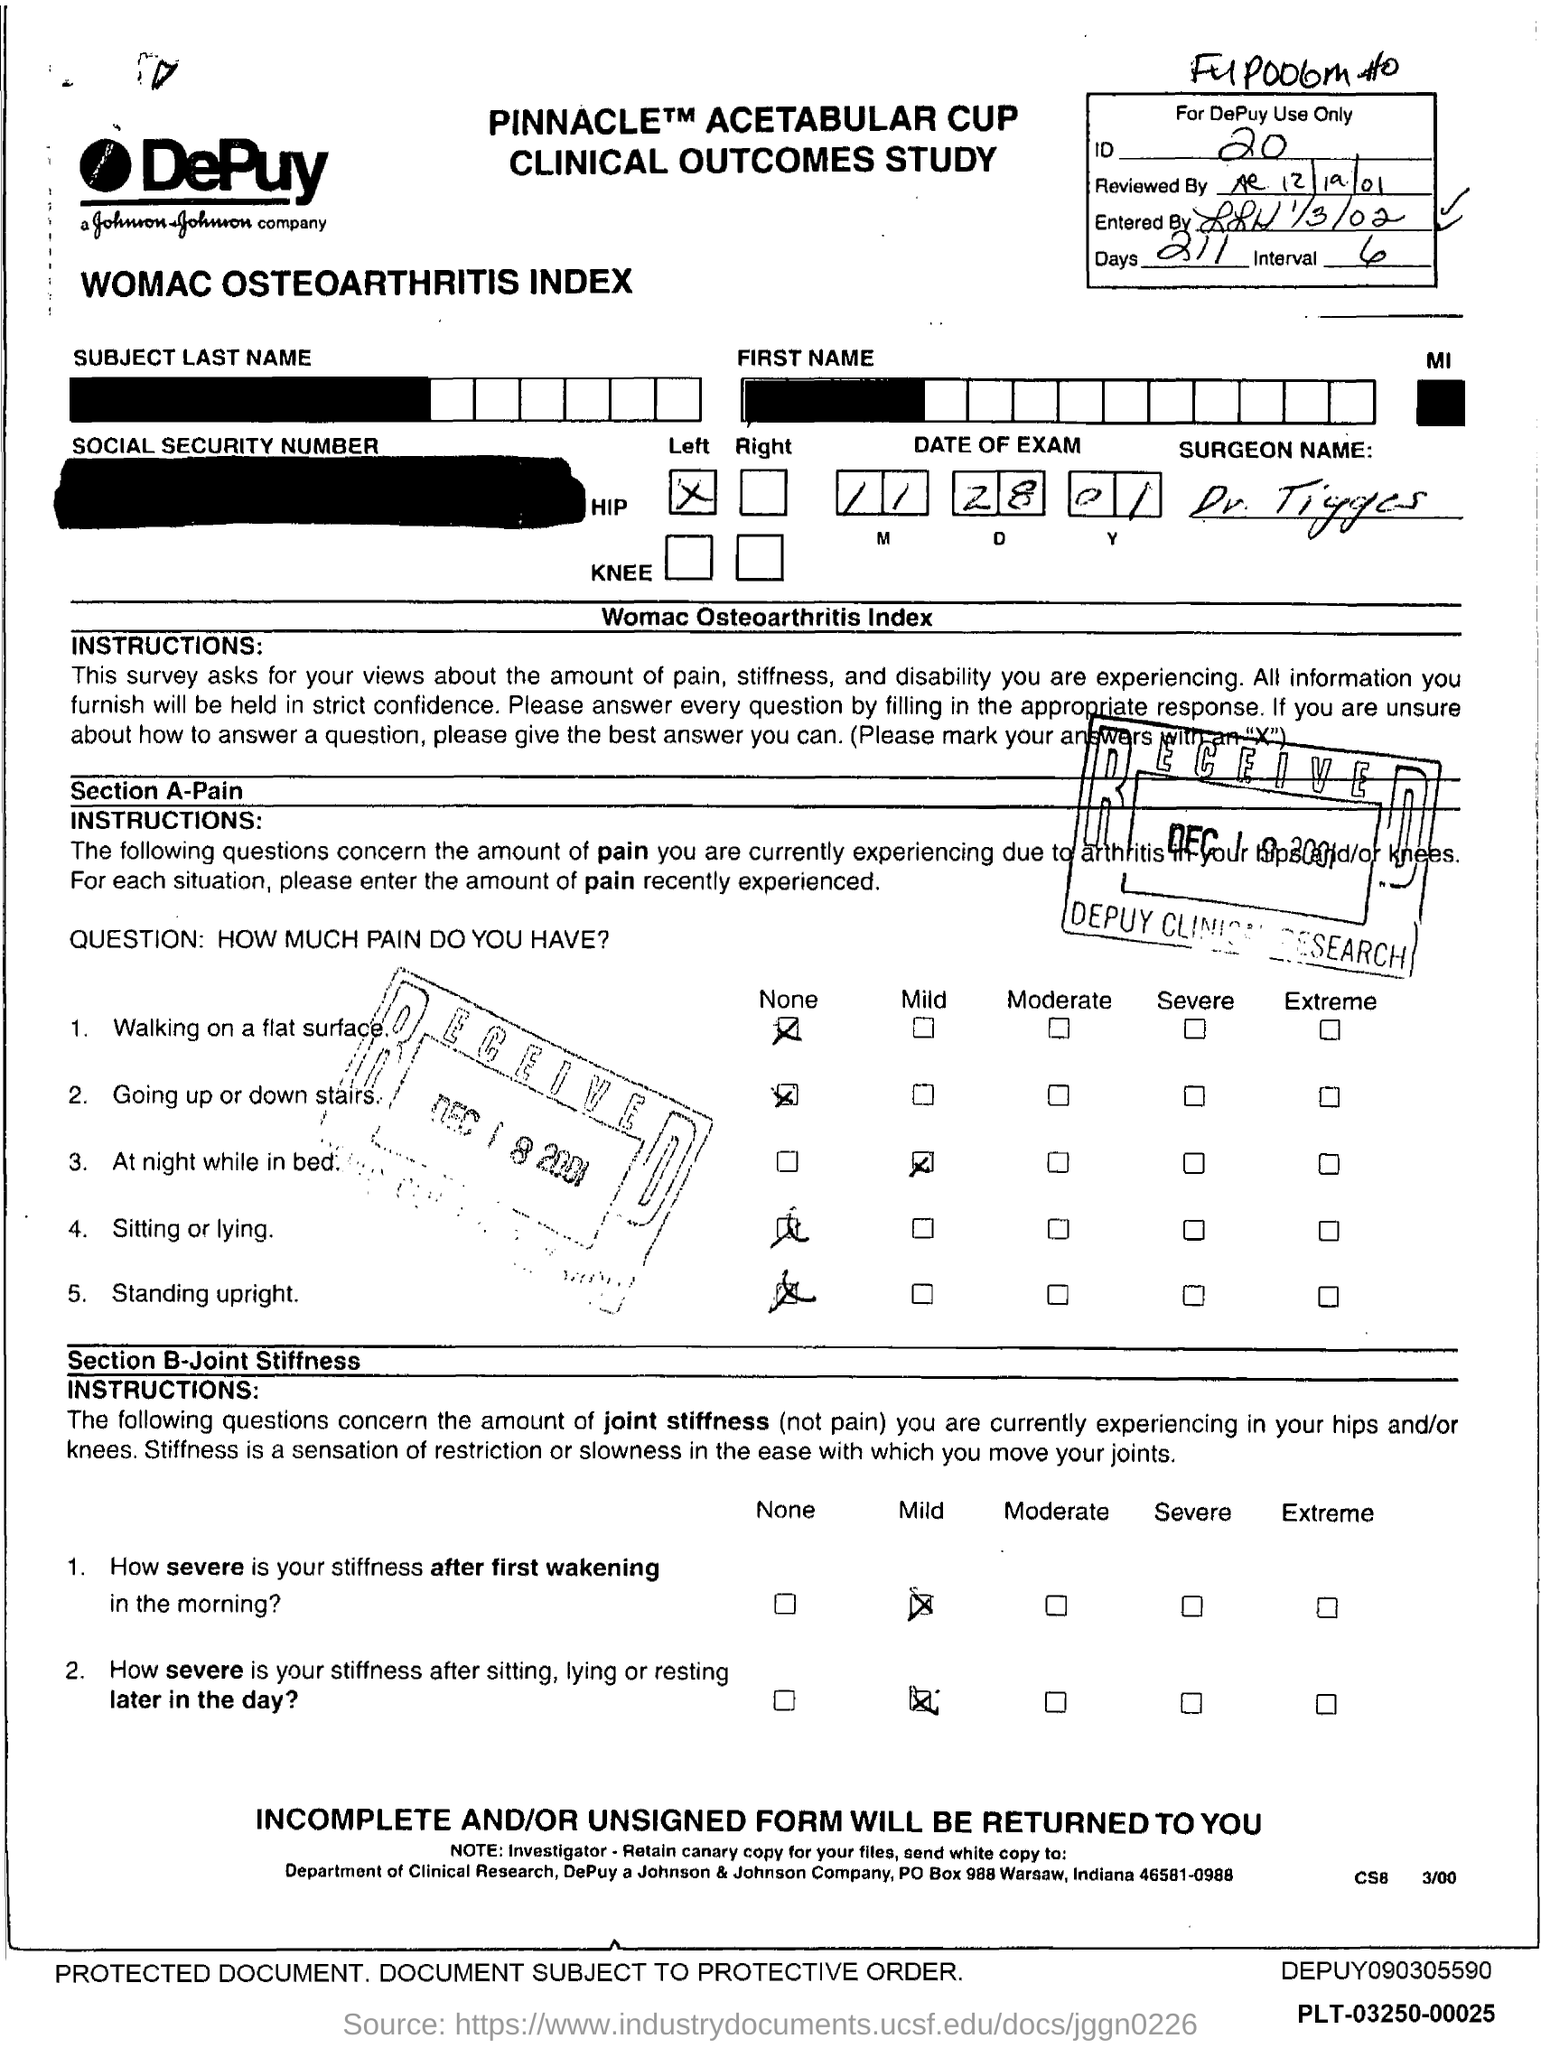Specify some key components in this picture. What are the days? 211..." is a question that is asking for information about the number of days that exist. The date of the exam is 11-28-01. The ID is 20. 